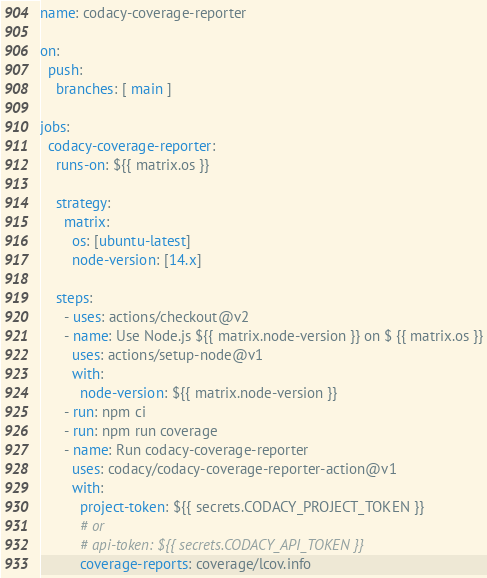Convert code to text. <code><loc_0><loc_0><loc_500><loc_500><_YAML_>name: codacy-coverage-reporter

on:
  push:
    branches: [ main ]

jobs:
  codacy-coverage-reporter:
    runs-on: ${{ matrix.os }}

    strategy:
      matrix:
        os: [ubuntu-latest]
        node-version: [14.x]

    steps:
      - uses: actions/checkout@v2
      - name: Use Node.js ${{ matrix.node-version }} on $ {{ matrix.os }}
        uses: actions/setup-node@v1
        with:
          node-version: ${{ matrix.node-version }}
      - run: npm ci
      - run: npm run coverage
      - name: Run codacy-coverage-reporter
        uses: codacy/codacy-coverage-reporter-action@v1
        with:
          project-token: ${{ secrets.CODACY_PROJECT_TOKEN }}
          # or
          # api-token: ${{ secrets.CODACY_API_TOKEN }}
          coverage-reports: coverage/lcov.info</code> 